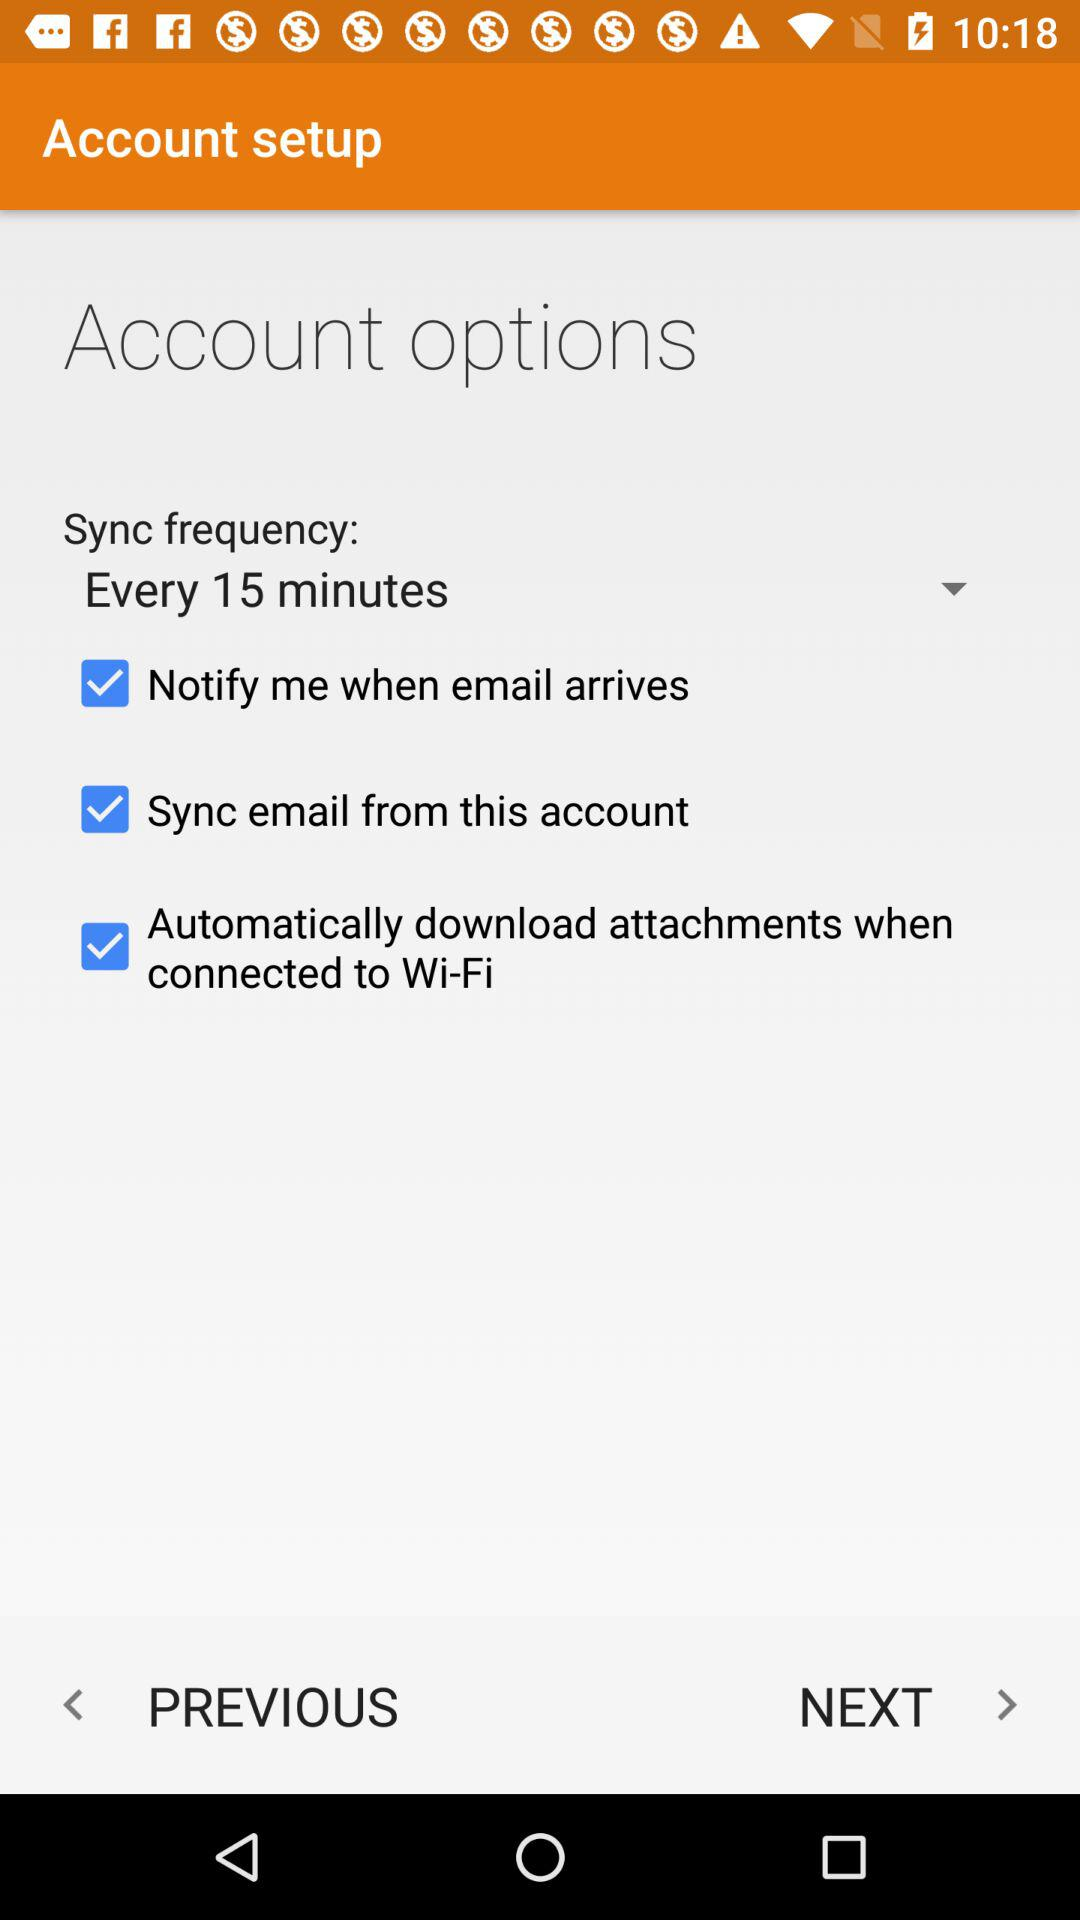How many checkbox options are there on the Account Options screen?
Answer the question using a single word or phrase. 3 